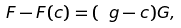Convert formula to latex. <formula><loc_0><loc_0><loc_500><loc_500>F - F ( { c } ) = ( \ g - { c } ) G ,</formula> 